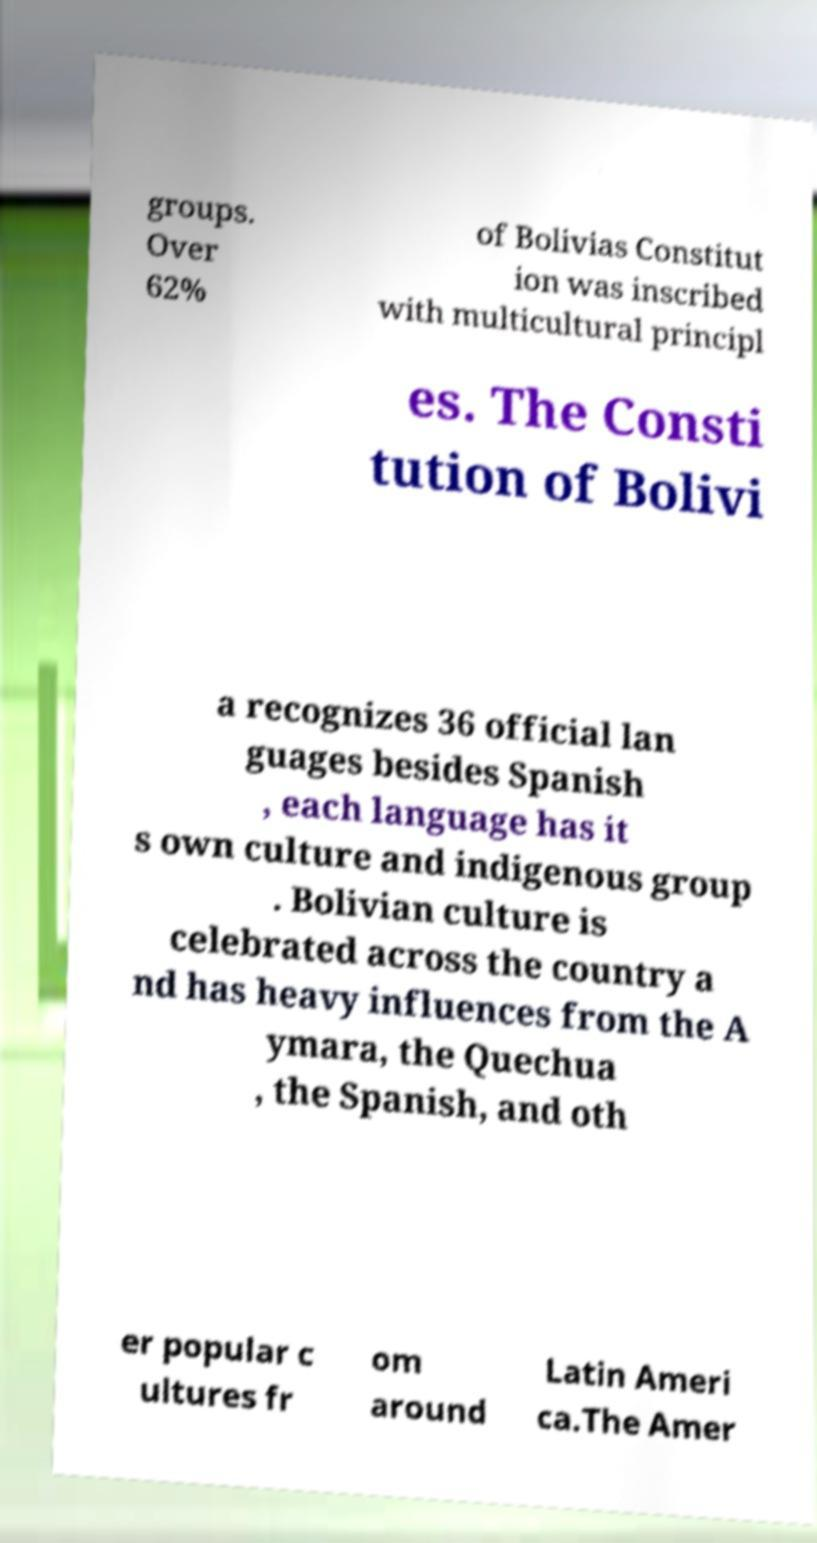Please identify and transcribe the text found in this image. groups. Over 62% of Bolivias Constitut ion was inscribed with multicultural principl es. The Consti tution of Bolivi a recognizes 36 official lan guages besides Spanish , each language has it s own culture and indigenous group . Bolivian culture is celebrated across the country a nd has heavy influences from the A ymara, the Quechua , the Spanish, and oth er popular c ultures fr om around Latin Ameri ca.The Amer 